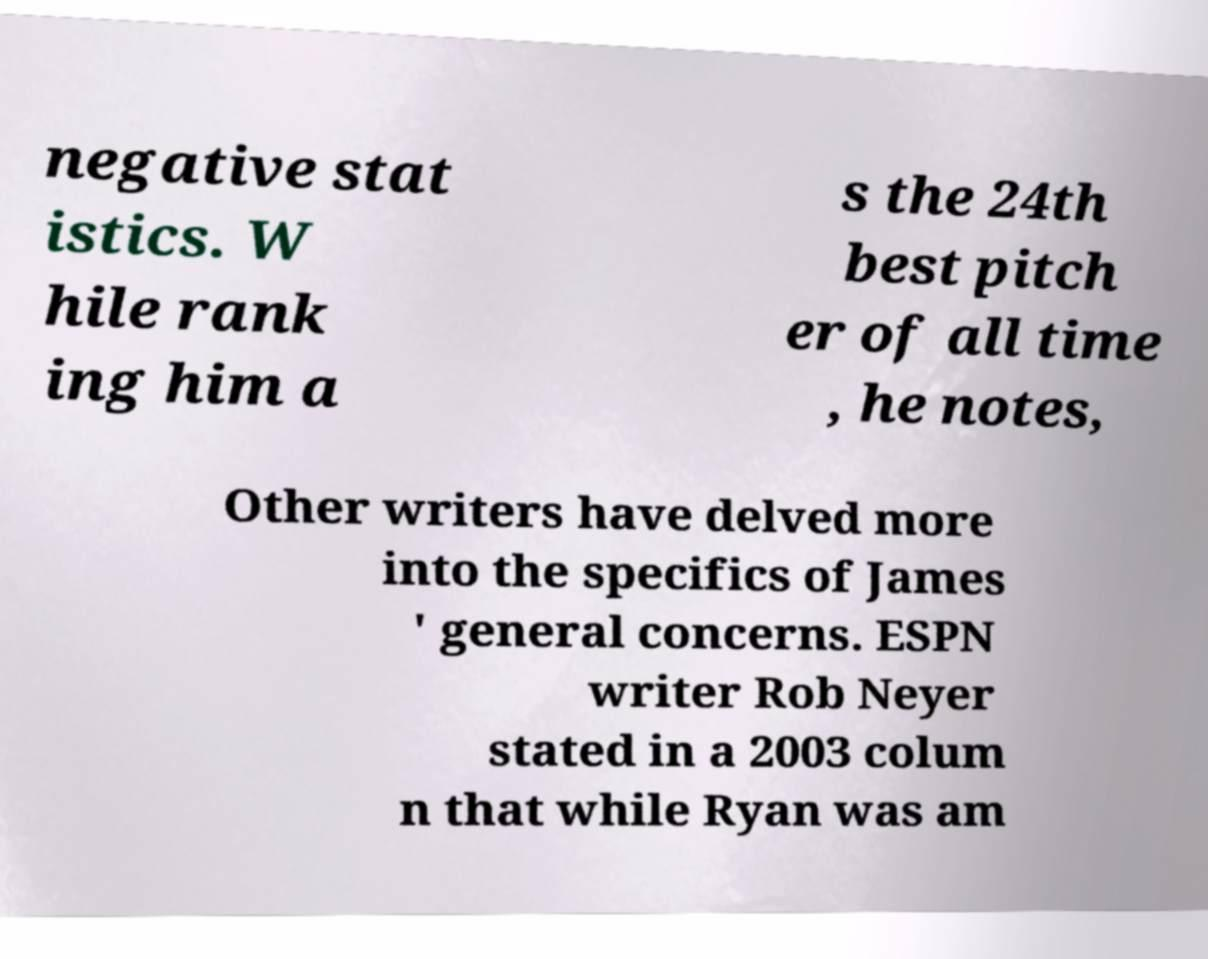What messages or text are displayed in this image? I need them in a readable, typed format. negative stat istics. W hile rank ing him a s the 24th best pitch er of all time , he notes, Other writers have delved more into the specifics of James ' general concerns. ESPN writer Rob Neyer stated in a 2003 colum n that while Ryan was am 